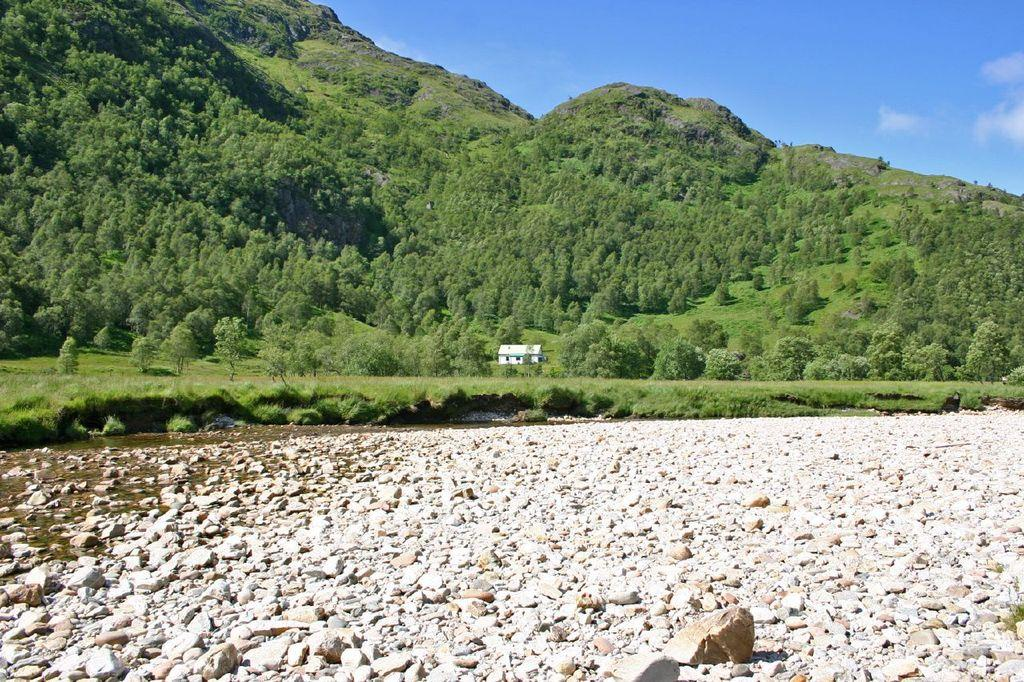What geographical features are located in the center of the image? There are hills in the center of the image. What can be found at the bottom of the image? There are rocks at the bottom of the image. What type of structure is present in the image? There is a shed in the image. What is visible at the top of the image? The sky is visible at the top of the image. What type of pie is being served on the island in the image? There is no island or pie present in the image; it features hills, rocks, a shed, and the sky. 